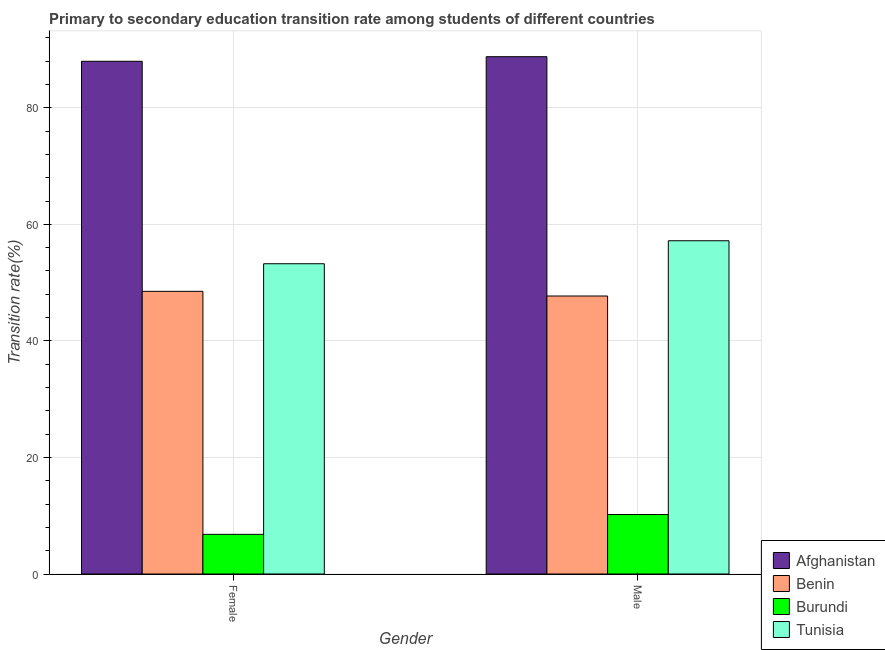How many groups of bars are there?
Give a very brief answer. 2. Are the number of bars on each tick of the X-axis equal?
Your answer should be compact. Yes. How many bars are there on the 1st tick from the left?
Your answer should be very brief. 4. What is the transition rate among male students in Benin?
Keep it short and to the point. 47.71. Across all countries, what is the maximum transition rate among male students?
Ensure brevity in your answer.  88.78. Across all countries, what is the minimum transition rate among female students?
Provide a short and direct response. 6.81. In which country was the transition rate among female students maximum?
Give a very brief answer. Afghanistan. In which country was the transition rate among female students minimum?
Ensure brevity in your answer.  Burundi. What is the total transition rate among female students in the graph?
Keep it short and to the point. 196.55. What is the difference between the transition rate among male students in Benin and that in Afghanistan?
Your answer should be compact. -41.07. What is the difference between the transition rate among male students in Benin and the transition rate among female students in Burundi?
Your answer should be compact. 40.9. What is the average transition rate among male students per country?
Offer a very short reply. 50.97. What is the difference between the transition rate among female students and transition rate among male students in Benin?
Offer a terse response. 0.8. In how many countries, is the transition rate among female students greater than 48 %?
Your answer should be very brief. 3. What is the ratio of the transition rate among male students in Benin to that in Afghanistan?
Provide a short and direct response. 0.54. Is the transition rate among male students in Afghanistan less than that in Benin?
Ensure brevity in your answer.  No. In how many countries, is the transition rate among female students greater than the average transition rate among female students taken over all countries?
Your answer should be very brief. 2. What does the 3rd bar from the left in Male represents?
Keep it short and to the point. Burundi. What does the 3rd bar from the right in Male represents?
Provide a succinct answer. Benin. How many bars are there?
Offer a terse response. 8. How many countries are there in the graph?
Your answer should be compact. 4. Are the values on the major ticks of Y-axis written in scientific E-notation?
Provide a succinct answer. No. Where does the legend appear in the graph?
Provide a succinct answer. Bottom right. How many legend labels are there?
Keep it short and to the point. 4. What is the title of the graph?
Offer a terse response. Primary to secondary education transition rate among students of different countries. Does "Sri Lanka" appear as one of the legend labels in the graph?
Provide a succinct answer. No. What is the label or title of the Y-axis?
Provide a succinct answer. Transition rate(%). What is the Transition rate(%) in Afghanistan in Female?
Ensure brevity in your answer.  87.99. What is the Transition rate(%) in Benin in Female?
Offer a terse response. 48.51. What is the Transition rate(%) of Burundi in Female?
Keep it short and to the point. 6.81. What is the Transition rate(%) in Tunisia in Female?
Make the answer very short. 53.24. What is the Transition rate(%) in Afghanistan in Male?
Offer a terse response. 88.78. What is the Transition rate(%) in Benin in Male?
Keep it short and to the point. 47.71. What is the Transition rate(%) of Burundi in Male?
Provide a short and direct response. 10.2. What is the Transition rate(%) of Tunisia in Male?
Give a very brief answer. 57.19. Across all Gender, what is the maximum Transition rate(%) of Afghanistan?
Keep it short and to the point. 88.78. Across all Gender, what is the maximum Transition rate(%) of Benin?
Offer a terse response. 48.51. Across all Gender, what is the maximum Transition rate(%) in Burundi?
Your answer should be very brief. 10.2. Across all Gender, what is the maximum Transition rate(%) in Tunisia?
Provide a short and direct response. 57.19. Across all Gender, what is the minimum Transition rate(%) in Afghanistan?
Offer a very short reply. 87.99. Across all Gender, what is the minimum Transition rate(%) in Benin?
Your response must be concise. 47.71. Across all Gender, what is the minimum Transition rate(%) of Burundi?
Provide a short and direct response. 6.81. Across all Gender, what is the minimum Transition rate(%) in Tunisia?
Your answer should be very brief. 53.24. What is the total Transition rate(%) of Afghanistan in the graph?
Your response must be concise. 176.76. What is the total Transition rate(%) in Benin in the graph?
Make the answer very short. 96.22. What is the total Transition rate(%) in Burundi in the graph?
Give a very brief answer. 17.01. What is the total Transition rate(%) in Tunisia in the graph?
Ensure brevity in your answer.  110.43. What is the difference between the Transition rate(%) in Afghanistan in Female and that in Male?
Your response must be concise. -0.79. What is the difference between the Transition rate(%) of Benin in Female and that in Male?
Offer a terse response. 0.8. What is the difference between the Transition rate(%) of Burundi in Female and that in Male?
Give a very brief answer. -3.4. What is the difference between the Transition rate(%) in Tunisia in Female and that in Male?
Your answer should be compact. -3.95. What is the difference between the Transition rate(%) of Afghanistan in Female and the Transition rate(%) of Benin in Male?
Your answer should be very brief. 40.28. What is the difference between the Transition rate(%) in Afghanistan in Female and the Transition rate(%) in Burundi in Male?
Your answer should be very brief. 77.78. What is the difference between the Transition rate(%) in Afghanistan in Female and the Transition rate(%) in Tunisia in Male?
Keep it short and to the point. 30.8. What is the difference between the Transition rate(%) of Benin in Female and the Transition rate(%) of Burundi in Male?
Your answer should be very brief. 38.3. What is the difference between the Transition rate(%) in Benin in Female and the Transition rate(%) in Tunisia in Male?
Ensure brevity in your answer.  -8.68. What is the difference between the Transition rate(%) of Burundi in Female and the Transition rate(%) of Tunisia in Male?
Offer a very short reply. -50.38. What is the average Transition rate(%) of Afghanistan per Gender?
Offer a terse response. 88.38. What is the average Transition rate(%) in Benin per Gender?
Offer a very short reply. 48.11. What is the average Transition rate(%) in Burundi per Gender?
Keep it short and to the point. 8.51. What is the average Transition rate(%) in Tunisia per Gender?
Offer a terse response. 55.22. What is the difference between the Transition rate(%) in Afghanistan and Transition rate(%) in Benin in Female?
Provide a short and direct response. 39.48. What is the difference between the Transition rate(%) of Afghanistan and Transition rate(%) of Burundi in Female?
Provide a short and direct response. 81.18. What is the difference between the Transition rate(%) in Afghanistan and Transition rate(%) in Tunisia in Female?
Keep it short and to the point. 34.74. What is the difference between the Transition rate(%) of Benin and Transition rate(%) of Burundi in Female?
Keep it short and to the point. 41.7. What is the difference between the Transition rate(%) in Benin and Transition rate(%) in Tunisia in Female?
Offer a terse response. -4.74. What is the difference between the Transition rate(%) of Burundi and Transition rate(%) of Tunisia in Female?
Your answer should be very brief. -46.44. What is the difference between the Transition rate(%) of Afghanistan and Transition rate(%) of Benin in Male?
Your answer should be compact. 41.07. What is the difference between the Transition rate(%) in Afghanistan and Transition rate(%) in Burundi in Male?
Provide a short and direct response. 78.57. What is the difference between the Transition rate(%) of Afghanistan and Transition rate(%) of Tunisia in Male?
Your answer should be very brief. 31.59. What is the difference between the Transition rate(%) of Benin and Transition rate(%) of Burundi in Male?
Provide a short and direct response. 37.5. What is the difference between the Transition rate(%) of Benin and Transition rate(%) of Tunisia in Male?
Your response must be concise. -9.48. What is the difference between the Transition rate(%) in Burundi and Transition rate(%) in Tunisia in Male?
Your answer should be very brief. -46.98. What is the ratio of the Transition rate(%) in Benin in Female to that in Male?
Your answer should be compact. 1.02. What is the ratio of the Transition rate(%) in Burundi in Female to that in Male?
Make the answer very short. 0.67. What is the difference between the highest and the second highest Transition rate(%) in Afghanistan?
Offer a very short reply. 0.79. What is the difference between the highest and the second highest Transition rate(%) of Benin?
Ensure brevity in your answer.  0.8. What is the difference between the highest and the second highest Transition rate(%) in Burundi?
Your answer should be very brief. 3.4. What is the difference between the highest and the second highest Transition rate(%) of Tunisia?
Give a very brief answer. 3.95. What is the difference between the highest and the lowest Transition rate(%) in Afghanistan?
Your answer should be compact. 0.79. What is the difference between the highest and the lowest Transition rate(%) of Benin?
Make the answer very short. 0.8. What is the difference between the highest and the lowest Transition rate(%) of Burundi?
Give a very brief answer. 3.4. What is the difference between the highest and the lowest Transition rate(%) in Tunisia?
Your response must be concise. 3.95. 